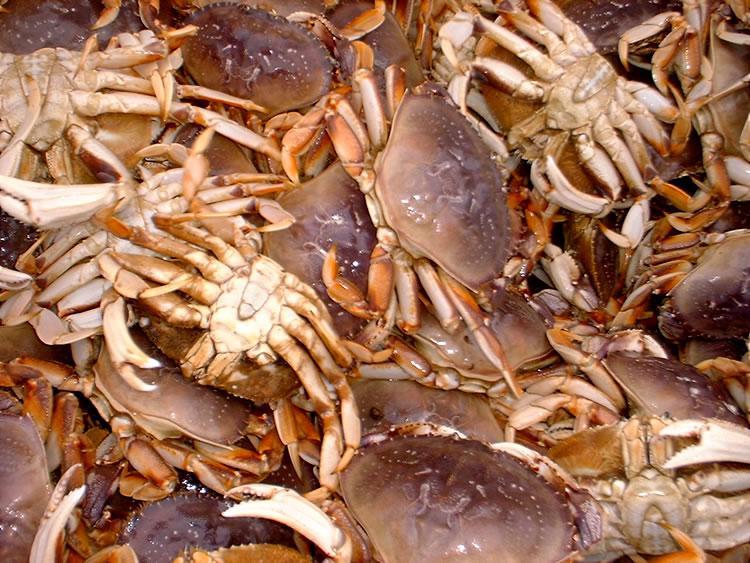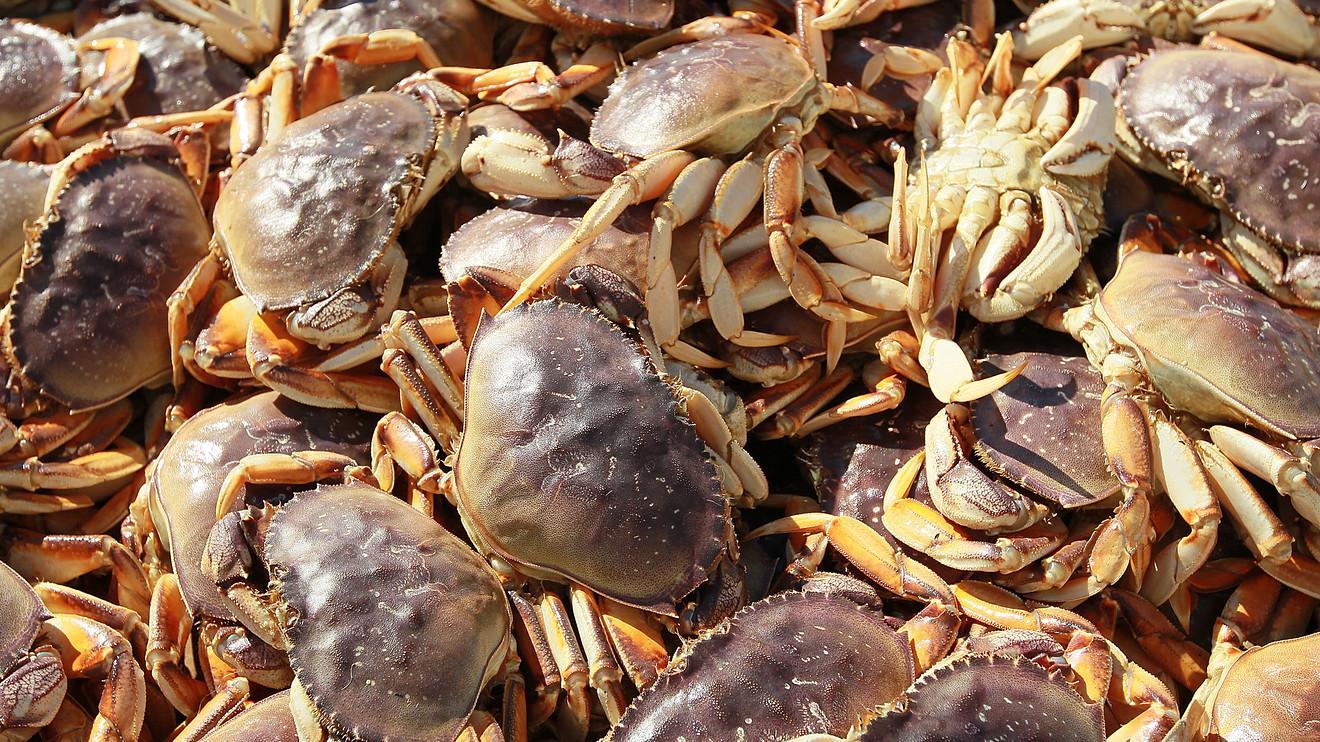The first image is the image on the left, the second image is the image on the right. For the images displayed, is the sentence "There are cables wrapping around the outside of the crate the crabs are in." factually correct? Answer yes or no. No. The first image is the image on the left, the second image is the image on the right. Given the left and right images, does the statement "The crabs in the image on the right are sitting in a brightly colored container." hold true? Answer yes or no. No. 